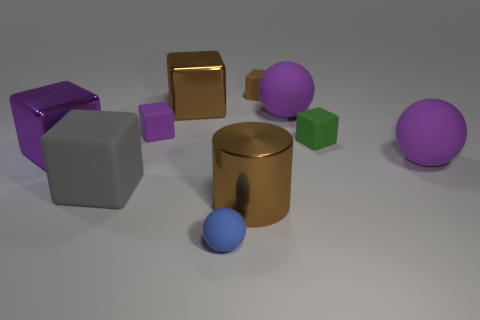Are there any yellow matte blocks that have the same size as the blue object?
Your answer should be compact. No. What is the material of the purple block that is the same size as the gray object?
Offer a very short reply. Metal. There is a blue object; is it the same size as the purple rubber thing that is behind the small purple rubber cube?
Your answer should be compact. No. There is a large cylinder that is on the right side of the big purple shiny block; what is its material?
Your response must be concise. Metal. Is the number of big gray cubes that are behind the gray matte block the same as the number of purple rubber things?
Offer a terse response. No. Do the gray rubber object and the green block have the same size?
Make the answer very short. No. Are there any large purple rubber spheres that are on the right side of the purple rubber thing that is in front of the large purple metallic block behind the gray cube?
Your response must be concise. No. There is a small purple object that is the same shape as the large gray thing; what is it made of?
Your answer should be very brief. Rubber. How many green blocks are on the right side of the brown shiny object behind the large brown shiny cylinder?
Give a very brief answer. 1. What is the size of the gray rubber cube in front of the big shiny object behind the cube on the right side of the tiny brown matte block?
Give a very brief answer. Large. 